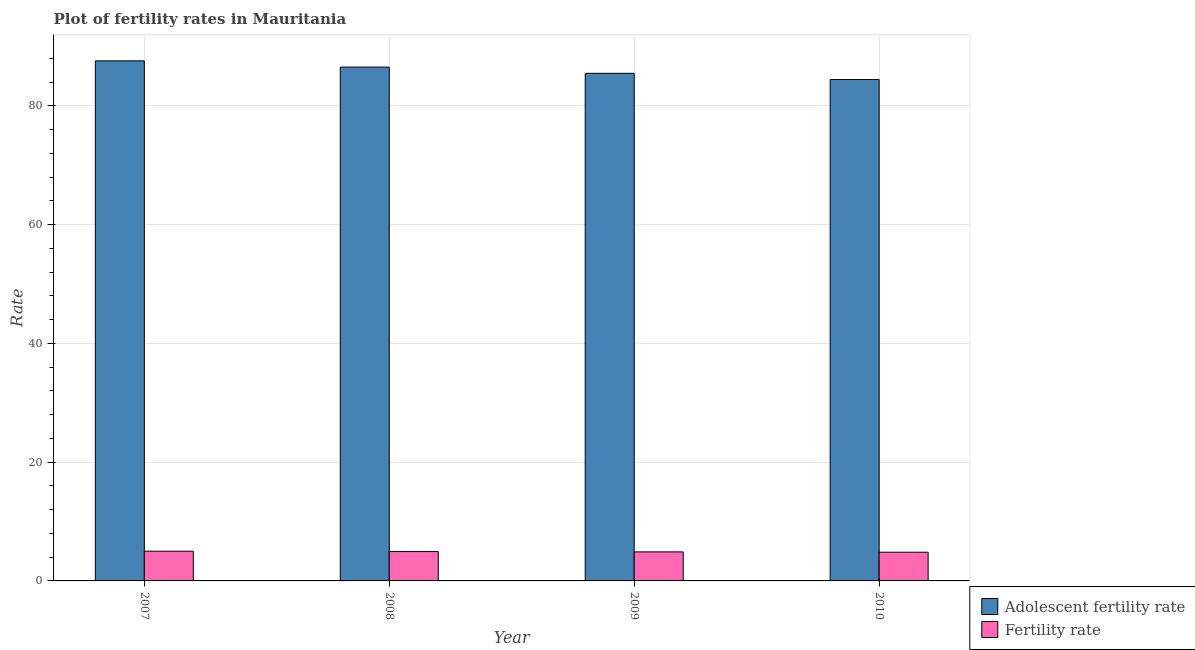In how many cases, is the number of bars for a given year not equal to the number of legend labels?
Provide a short and direct response. 0. What is the fertility rate in 2008?
Keep it short and to the point. 4.95. Across all years, what is the maximum adolescent fertility rate?
Your answer should be compact. 87.57. Across all years, what is the minimum adolescent fertility rate?
Give a very brief answer. 84.43. In which year was the adolescent fertility rate maximum?
Ensure brevity in your answer.  2007. In which year was the adolescent fertility rate minimum?
Ensure brevity in your answer.  2010. What is the total adolescent fertility rate in the graph?
Give a very brief answer. 344. What is the difference between the adolescent fertility rate in 2009 and that in 2010?
Provide a succinct answer. 1.05. What is the difference between the fertility rate in 2009 and the adolescent fertility rate in 2007?
Your answer should be very brief. -0.11. What is the average fertility rate per year?
Give a very brief answer. 4.92. What is the ratio of the fertility rate in 2007 to that in 2010?
Your answer should be compact. 1.03. What is the difference between the highest and the second highest fertility rate?
Ensure brevity in your answer.  0.05. What is the difference between the highest and the lowest fertility rate?
Provide a short and direct response. 0.17. In how many years, is the adolescent fertility rate greater than the average adolescent fertility rate taken over all years?
Offer a terse response. 2. Is the sum of the adolescent fertility rate in 2007 and 2009 greater than the maximum fertility rate across all years?
Offer a very short reply. Yes. What does the 2nd bar from the left in 2007 represents?
Offer a terse response. Fertility rate. What does the 2nd bar from the right in 2010 represents?
Your response must be concise. Adolescent fertility rate. How many bars are there?
Offer a terse response. 8. How many years are there in the graph?
Offer a terse response. 4. What is the difference between two consecutive major ticks on the Y-axis?
Ensure brevity in your answer.  20. Does the graph contain any zero values?
Provide a succinct answer. No. What is the title of the graph?
Your answer should be compact. Plot of fertility rates in Mauritania. What is the label or title of the X-axis?
Give a very brief answer. Year. What is the label or title of the Y-axis?
Your response must be concise. Rate. What is the Rate in Adolescent fertility rate in 2007?
Your answer should be very brief. 87.57. What is the Rate in Fertility rate in 2007?
Keep it short and to the point. 5. What is the Rate in Adolescent fertility rate in 2008?
Provide a short and direct response. 86.52. What is the Rate in Fertility rate in 2008?
Make the answer very short. 4.95. What is the Rate in Adolescent fertility rate in 2009?
Offer a very short reply. 85.48. What is the Rate of Fertility rate in 2009?
Provide a succinct answer. 4.89. What is the Rate of Adolescent fertility rate in 2010?
Make the answer very short. 84.43. What is the Rate of Fertility rate in 2010?
Your answer should be very brief. 4.83. Across all years, what is the maximum Rate in Adolescent fertility rate?
Provide a short and direct response. 87.57. Across all years, what is the maximum Rate of Fertility rate?
Offer a terse response. 5. Across all years, what is the minimum Rate in Adolescent fertility rate?
Provide a short and direct response. 84.43. Across all years, what is the minimum Rate of Fertility rate?
Make the answer very short. 4.83. What is the total Rate in Adolescent fertility rate in the graph?
Keep it short and to the point. 344. What is the total Rate of Fertility rate in the graph?
Ensure brevity in your answer.  19.68. What is the difference between the Rate of Adolescent fertility rate in 2007 and that in 2008?
Your answer should be compact. 1.05. What is the difference between the Rate of Fertility rate in 2007 and that in 2008?
Your answer should be very brief. 0.06. What is the difference between the Rate of Adolescent fertility rate in 2007 and that in 2009?
Offer a terse response. 2.09. What is the difference between the Rate in Fertility rate in 2007 and that in 2009?
Provide a succinct answer. 0.11. What is the difference between the Rate in Adolescent fertility rate in 2007 and that in 2010?
Your answer should be very brief. 3.14. What is the difference between the Rate of Fertility rate in 2007 and that in 2010?
Make the answer very short. 0.17. What is the difference between the Rate in Adolescent fertility rate in 2008 and that in 2009?
Offer a terse response. 1.05. What is the difference between the Rate of Fertility rate in 2008 and that in 2009?
Give a very brief answer. 0.06. What is the difference between the Rate in Adolescent fertility rate in 2008 and that in 2010?
Make the answer very short. 2.09. What is the difference between the Rate of Fertility rate in 2008 and that in 2010?
Your answer should be compact. 0.11. What is the difference between the Rate in Adolescent fertility rate in 2009 and that in 2010?
Your answer should be compact. 1.05. What is the difference between the Rate in Fertility rate in 2009 and that in 2010?
Provide a short and direct response. 0.06. What is the difference between the Rate in Adolescent fertility rate in 2007 and the Rate in Fertility rate in 2008?
Offer a terse response. 82.62. What is the difference between the Rate in Adolescent fertility rate in 2007 and the Rate in Fertility rate in 2009?
Offer a terse response. 82.68. What is the difference between the Rate in Adolescent fertility rate in 2007 and the Rate in Fertility rate in 2010?
Provide a short and direct response. 82.73. What is the difference between the Rate in Adolescent fertility rate in 2008 and the Rate in Fertility rate in 2009?
Ensure brevity in your answer.  81.63. What is the difference between the Rate in Adolescent fertility rate in 2008 and the Rate in Fertility rate in 2010?
Ensure brevity in your answer.  81.69. What is the difference between the Rate in Adolescent fertility rate in 2009 and the Rate in Fertility rate in 2010?
Provide a succinct answer. 80.64. What is the average Rate of Adolescent fertility rate per year?
Provide a succinct answer. 86. What is the average Rate of Fertility rate per year?
Provide a succinct answer. 4.92. In the year 2007, what is the difference between the Rate of Adolescent fertility rate and Rate of Fertility rate?
Keep it short and to the point. 82.57. In the year 2008, what is the difference between the Rate in Adolescent fertility rate and Rate in Fertility rate?
Provide a short and direct response. 81.58. In the year 2009, what is the difference between the Rate in Adolescent fertility rate and Rate in Fertility rate?
Make the answer very short. 80.59. In the year 2010, what is the difference between the Rate of Adolescent fertility rate and Rate of Fertility rate?
Provide a succinct answer. 79.6. What is the ratio of the Rate of Adolescent fertility rate in 2007 to that in 2008?
Keep it short and to the point. 1.01. What is the ratio of the Rate of Fertility rate in 2007 to that in 2008?
Your response must be concise. 1.01. What is the ratio of the Rate of Adolescent fertility rate in 2007 to that in 2009?
Offer a very short reply. 1.02. What is the ratio of the Rate in Fertility rate in 2007 to that in 2009?
Give a very brief answer. 1.02. What is the ratio of the Rate of Adolescent fertility rate in 2007 to that in 2010?
Your answer should be very brief. 1.04. What is the ratio of the Rate of Fertility rate in 2007 to that in 2010?
Give a very brief answer. 1.03. What is the ratio of the Rate in Adolescent fertility rate in 2008 to that in 2009?
Provide a succinct answer. 1.01. What is the ratio of the Rate in Fertility rate in 2008 to that in 2009?
Offer a terse response. 1.01. What is the ratio of the Rate of Adolescent fertility rate in 2008 to that in 2010?
Provide a succinct answer. 1.02. What is the ratio of the Rate in Fertility rate in 2008 to that in 2010?
Keep it short and to the point. 1.02. What is the ratio of the Rate in Adolescent fertility rate in 2009 to that in 2010?
Offer a terse response. 1.01. What is the ratio of the Rate in Fertility rate in 2009 to that in 2010?
Your answer should be compact. 1.01. What is the difference between the highest and the second highest Rate in Adolescent fertility rate?
Your response must be concise. 1.05. What is the difference between the highest and the second highest Rate of Fertility rate?
Your answer should be compact. 0.06. What is the difference between the highest and the lowest Rate of Adolescent fertility rate?
Provide a succinct answer. 3.14. What is the difference between the highest and the lowest Rate in Fertility rate?
Your response must be concise. 0.17. 